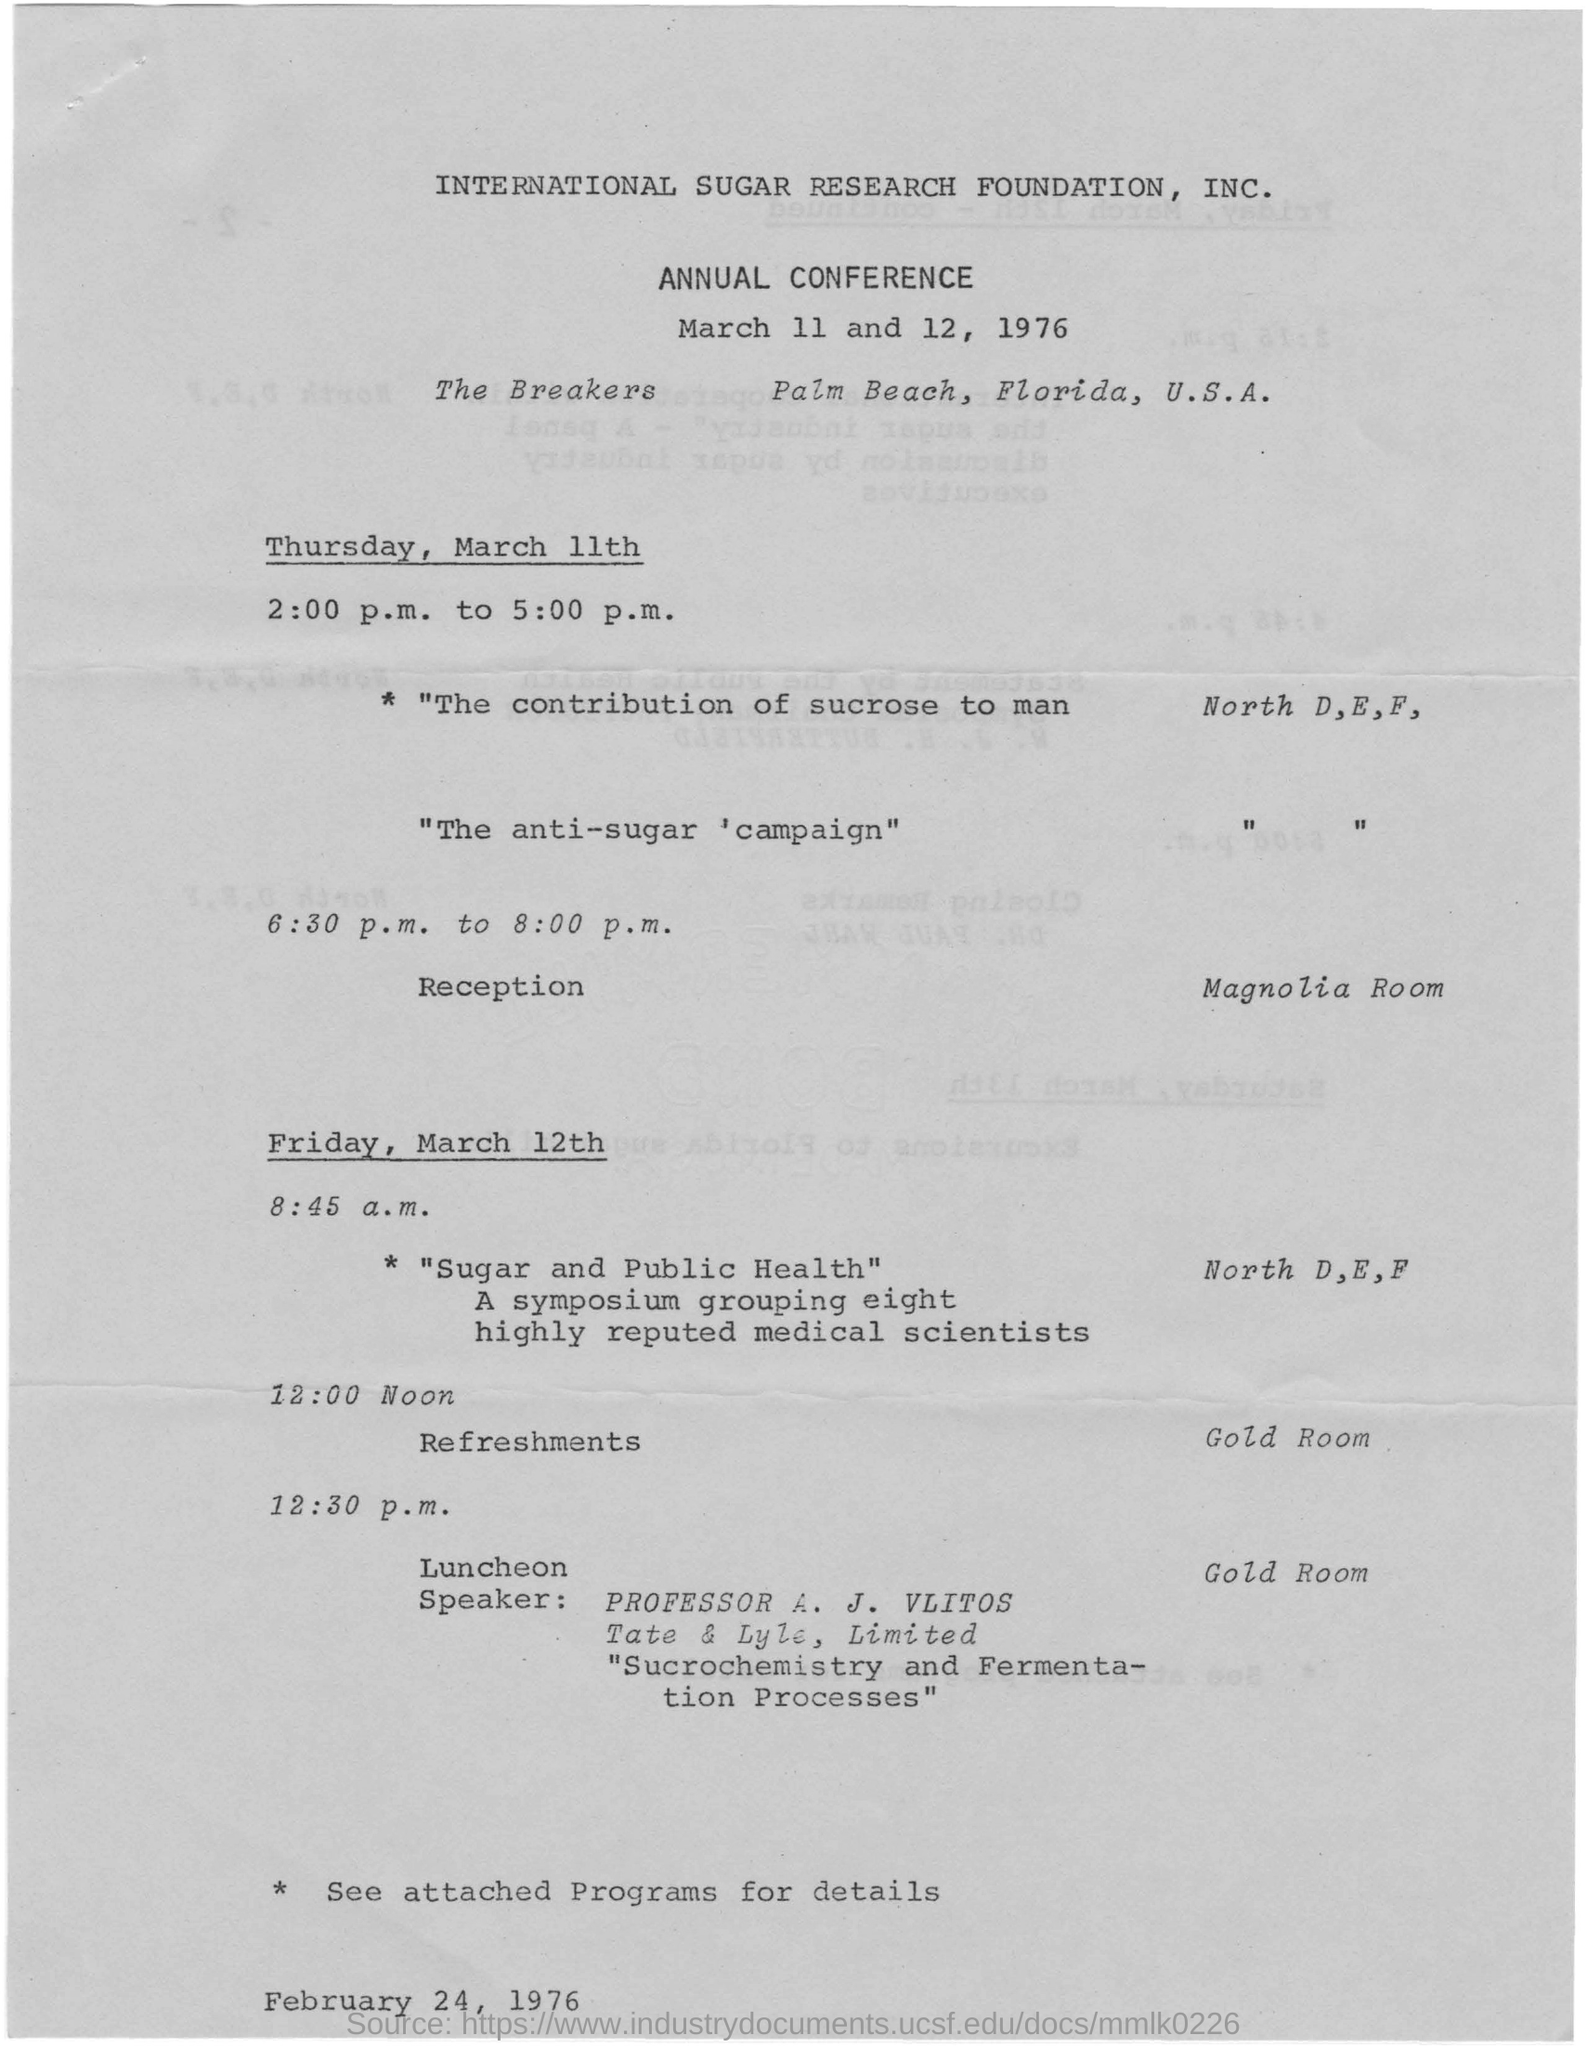List a handful of essential elements in this visual. The symposium is about the topic of sugar and its impact on public health. The speaker at the luncheon is Professor A. J. VLITOS. The location of the annual conference is The Breakers in Palm Beach, Florida, United States. The reception is being held in the Mangolia room. 